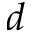<formula> <loc_0><loc_0><loc_500><loc_500>d</formula> 